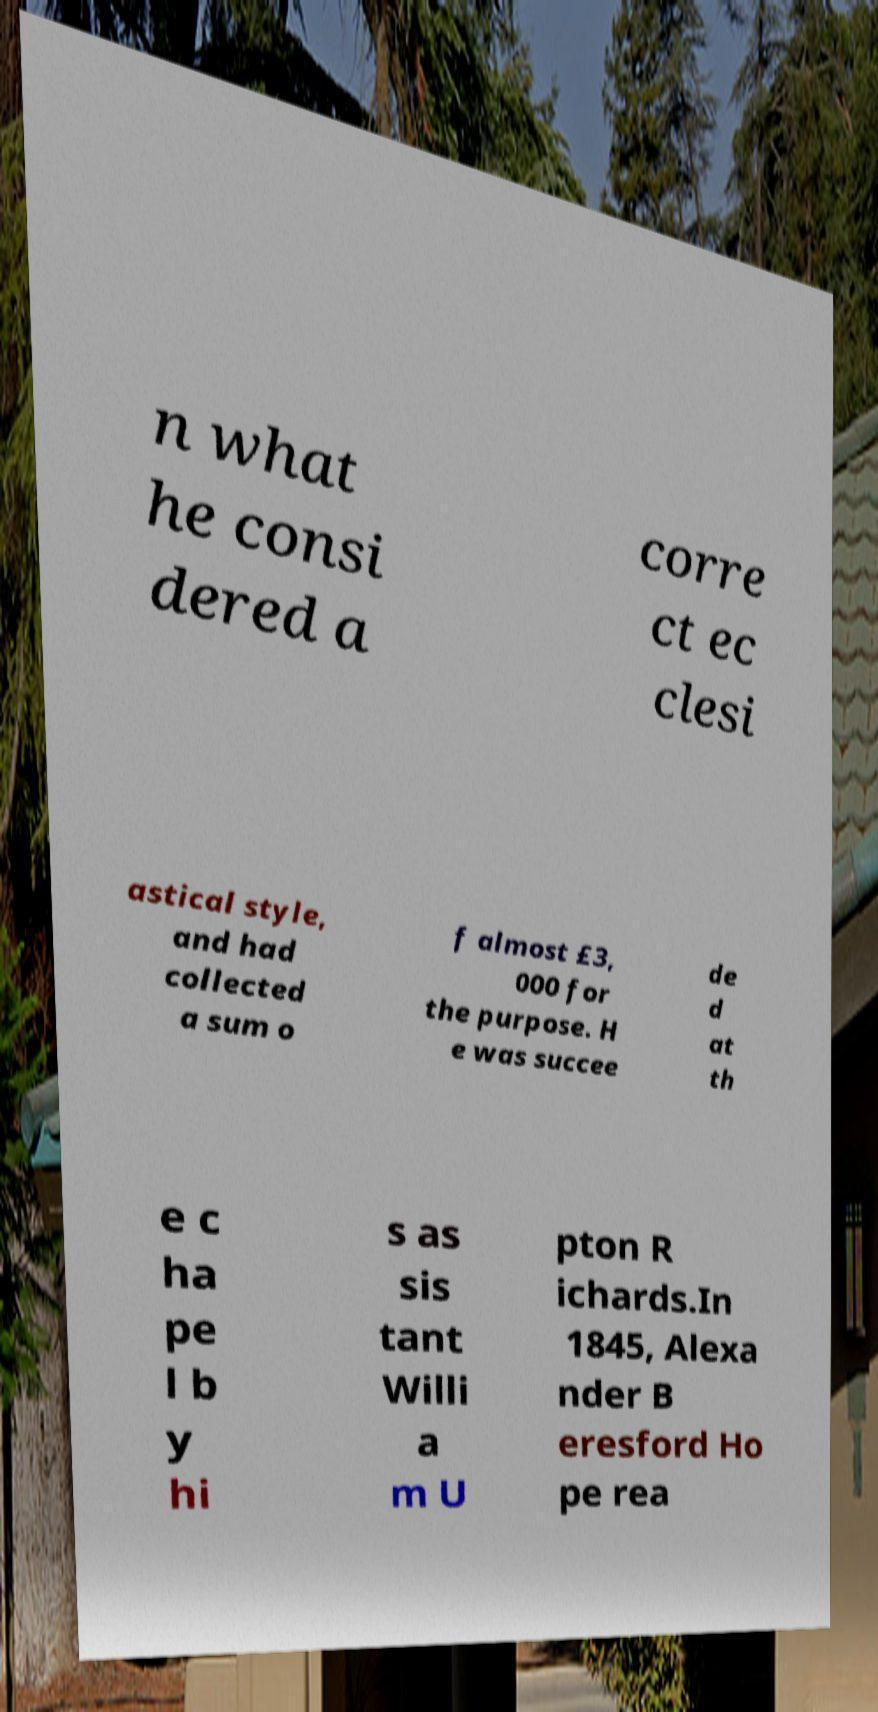For documentation purposes, I need the text within this image transcribed. Could you provide that? n what he consi dered a corre ct ec clesi astical style, and had collected a sum o f almost £3, 000 for the purpose. H e was succee de d at th e c ha pe l b y hi s as sis tant Willi a m U pton R ichards.In 1845, Alexa nder B eresford Ho pe rea 